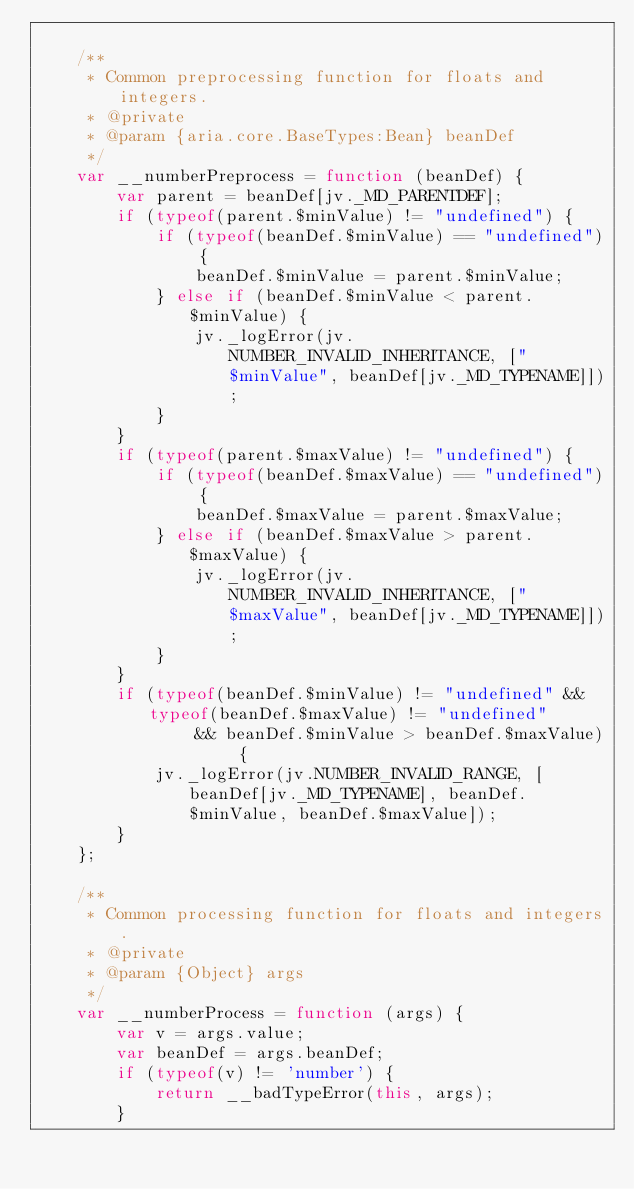Convert code to text. <code><loc_0><loc_0><loc_500><loc_500><_JavaScript_>
    /**
     * Common preprocessing function for floats and integers.
     * @private
     * @param {aria.core.BaseTypes:Bean} beanDef
     */
    var __numberPreprocess = function (beanDef) {
        var parent = beanDef[jv._MD_PARENTDEF];
        if (typeof(parent.$minValue) != "undefined") {
            if (typeof(beanDef.$minValue) == "undefined") {
                beanDef.$minValue = parent.$minValue;
            } else if (beanDef.$minValue < parent.$minValue) {
                jv._logError(jv.NUMBER_INVALID_INHERITANCE, ["$minValue", beanDef[jv._MD_TYPENAME]]);
            }
        }
        if (typeof(parent.$maxValue) != "undefined") {
            if (typeof(beanDef.$maxValue) == "undefined") {
                beanDef.$maxValue = parent.$maxValue;
            } else if (beanDef.$maxValue > parent.$maxValue) {
                jv._logError(jv.NUMBER_INVALID_INHERITANCE, ["$maxValue", beanDef[jv._MD_TYPENAME]]);
            }
        }
        if (typeof(beanDef.$minValue) != "undefined" && typeof(beanDef.$maxValue) != "undefined"
                && beanDef.$minValue > beanDef.$maxValue) {
            jv._logError(jv.NUMBER_INVALID_RANGE, [beanDef[jv._MD_TYPENAME], beanDef.$minValue, beanDef.$maxValue]);
        }
    };

    /**
     * Common processing function for floats and integers.
     * @private
     * @param {Object} args
     */
    var __numberProcess = function (args) {
        var v = args.value;
        var beanDef = args.beanDef;
        if (typeof(v) != 'number') {
            return __badTypeError(this, args);
        }</code> 